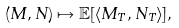Convert formula to latex. <formula><loc_0><loc_0><loc_500><loc_500>( M , N ) \mapsto \mathbb { E } [ \langle M _ { T } , N _ { T } \rangle ] ,</formula> 